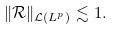Convert formula to latex. <formula><loc_0><loc_0><loc_500><loc_500>\| \mathcal { R } \| _ { \mathcal { L } ( L ^ { p } ) } \lesssim 1 .</formula> 